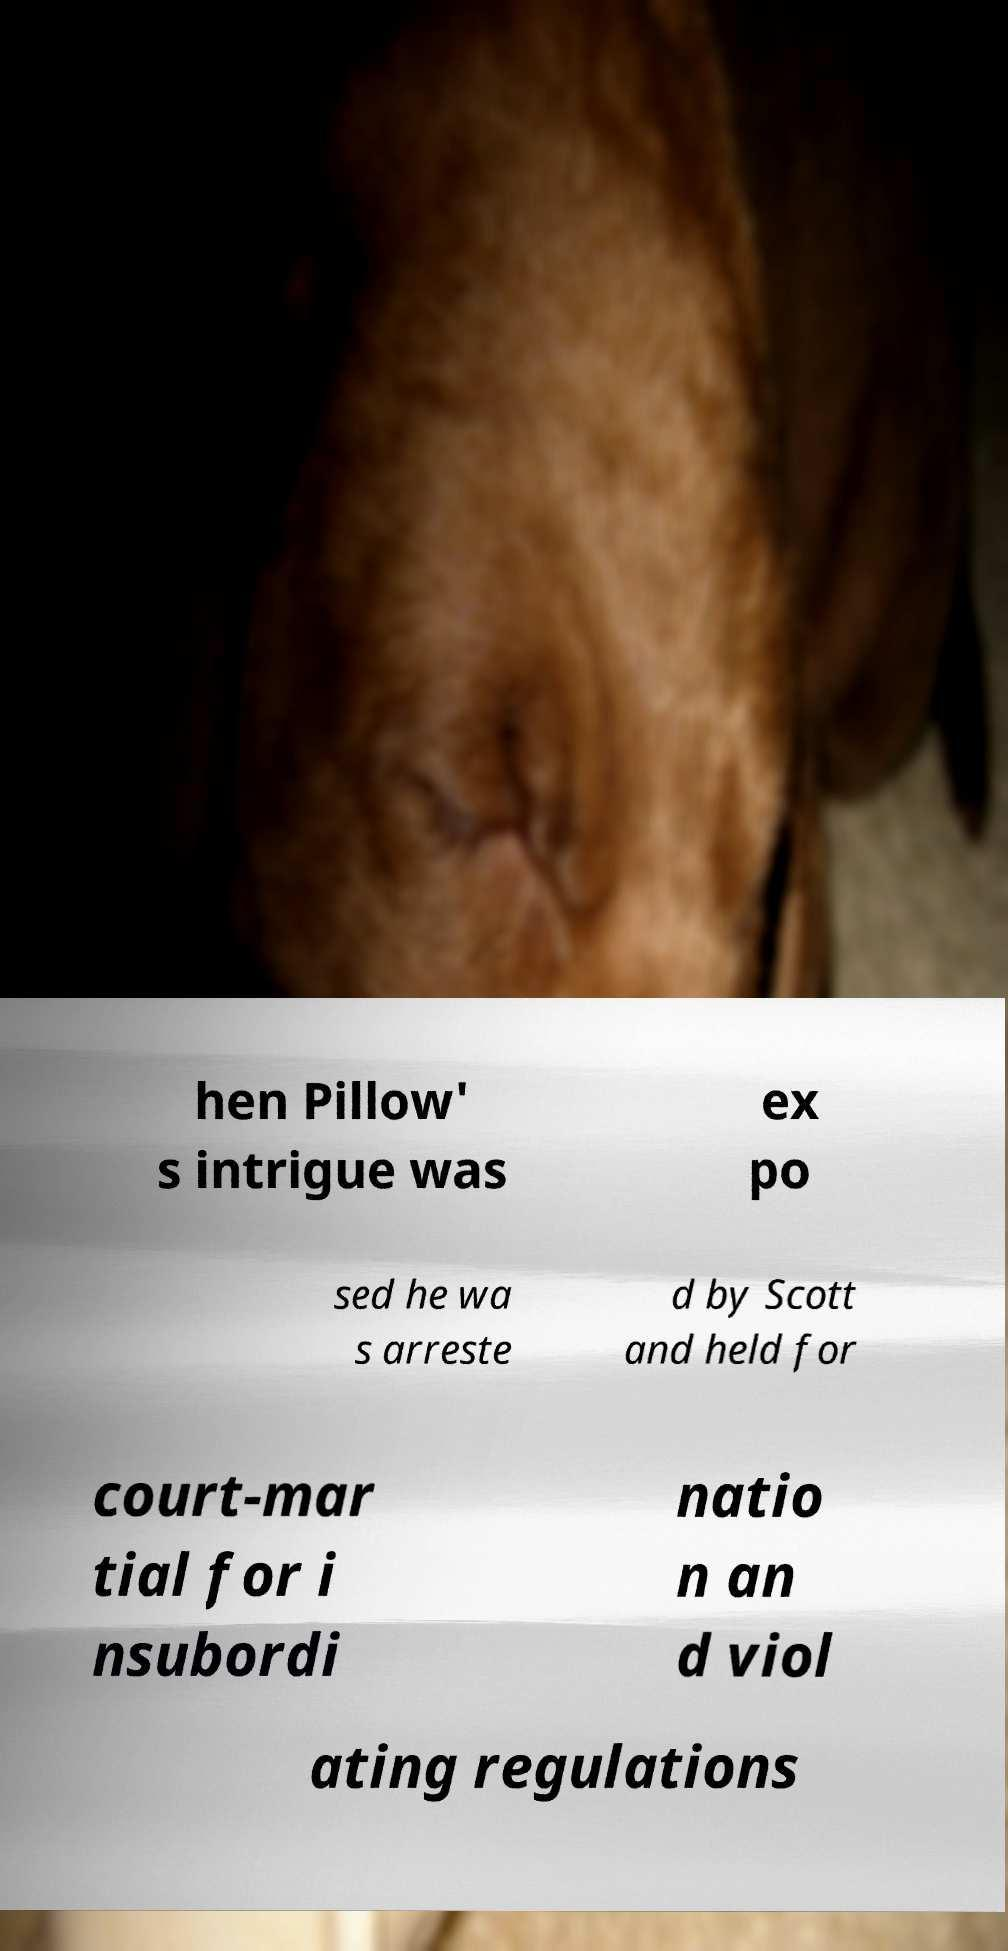Please read and relay the text visible in this image. What does it say? hen Pillow' s intrigue was ex po sed he wa s arreste d by Scott and held for court-mar tial for i nsubordi natio n an d viol ating regulations 